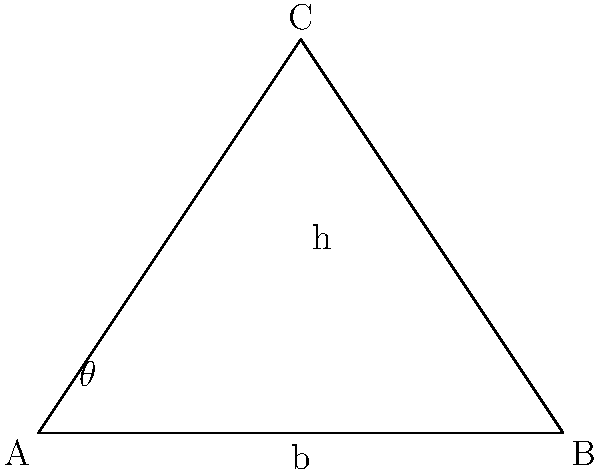Ancient alien theorists suggest that the Great Pyramid of Giza was built with advanced extraterrestrial technology. If the base half-width of the pyramid is 115.5 meters and its height is 146.5 meters, what is the angle $\theta$ between the base and the slope of the pyramid? This angle might reveal hidden cosmic alignments or energy focusing properties. Let's approach this step-by-step:

1) We can use the tangent function to find the angle. In a right-angled triangle, $\tan(\theta) = \frac{\text{opposite}}{\text{adjacent}}$.

2) In our case:
   - The opposite side is the height of the pyramid: 146.5 meters
   - The adjacent side is the base half-width: 115.5 meters

3) So, we can set up the equation:

   $$\tan(\theta) = \frac{146.5}{115.5}$$

4) To find $\theta$, we need to use the inverse tangent (arctangent) function:

   $$\theta = \arctan(\frac{146.5}{115.5})$$

5) Using a calculator or computer:

   $$\theta \approx 51.84^\circ$$

6) This angle is very close to 51.85°, which some theorists claim aligns with sacred geometry and cosmic ratios, potentially indicating extraterrestrial influence in its design.
Answer: $51.84^\circ$ 